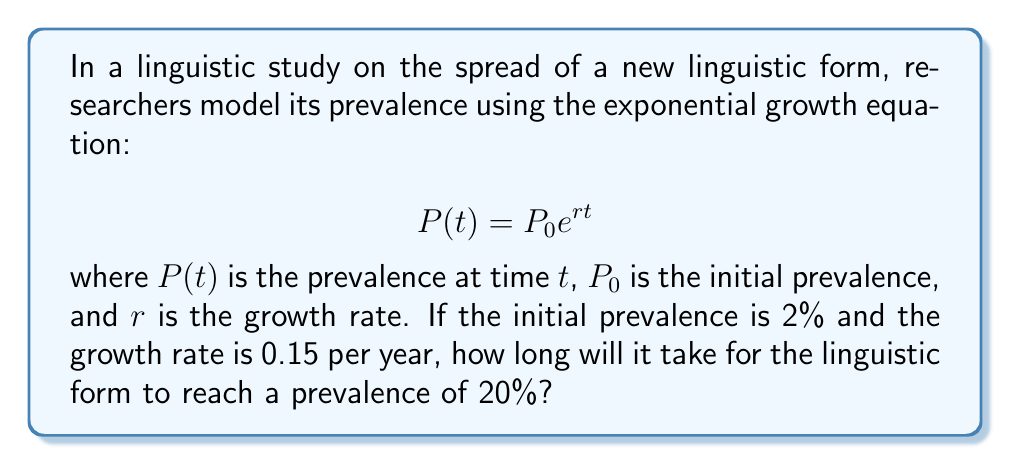Could you help me with this problem? To solve this problem, we'll use the given exponential growth equation and the provided information:

1. Initial prevalence $P_0 = 2\% = 0.02$
2. Growth rate $r = 0.15$ per year
3. Target prevalence $P(t) = 20\% = 0.2$

We need to solve for $t$ in the equation:

$$0.2 = 0.02 e^{0.15t}$$

Let's solve this step-by-step:

1. Divide both sides by 0.02:
   $$10 = e^{0.15t}$$

2. Take the natural logarithm of both sides:
   $$\ln(10) = \ln(e^{0.15t})$$

3. Simplify the right side using the properties of logarithms:
   $$\ln(10) = 0.15t$$

4. Divide both sides by 0.15 to isolate $t$:
   $$t = \frac{\ln(10)}{0.15}$$

5. Calculate the final result:
   $$t = \frac{2.30259}{0.15} \approx 15.35$$

Therefore, it will take approximately 15.35 years for the linguistic form to reach a prevalence of 20%.
Answer: 15.35 years 